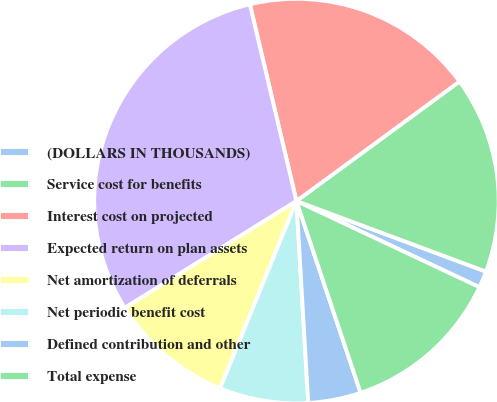<chart> <loc_0><loc_0><loc_500><loc_500><pie_chart><fcel>(DOLLARS IN THOUSANDS)<fcel>Service cost for benefits<fcel>Interest cost on projected<fcel>Expected return on plan assets<fcel>Net amortization of deferrals<fcel>Net periodic benefit cost<fcel>Defined contribution and other<fcel>Total expense<nl><fcel>1.33%<fcel>15.74%<fcel>18.63%<fcel>30.16%<fcel>9.98%<fcel>7.09%<fcel>4.21%<fcel>12.86%<nl></chart> 